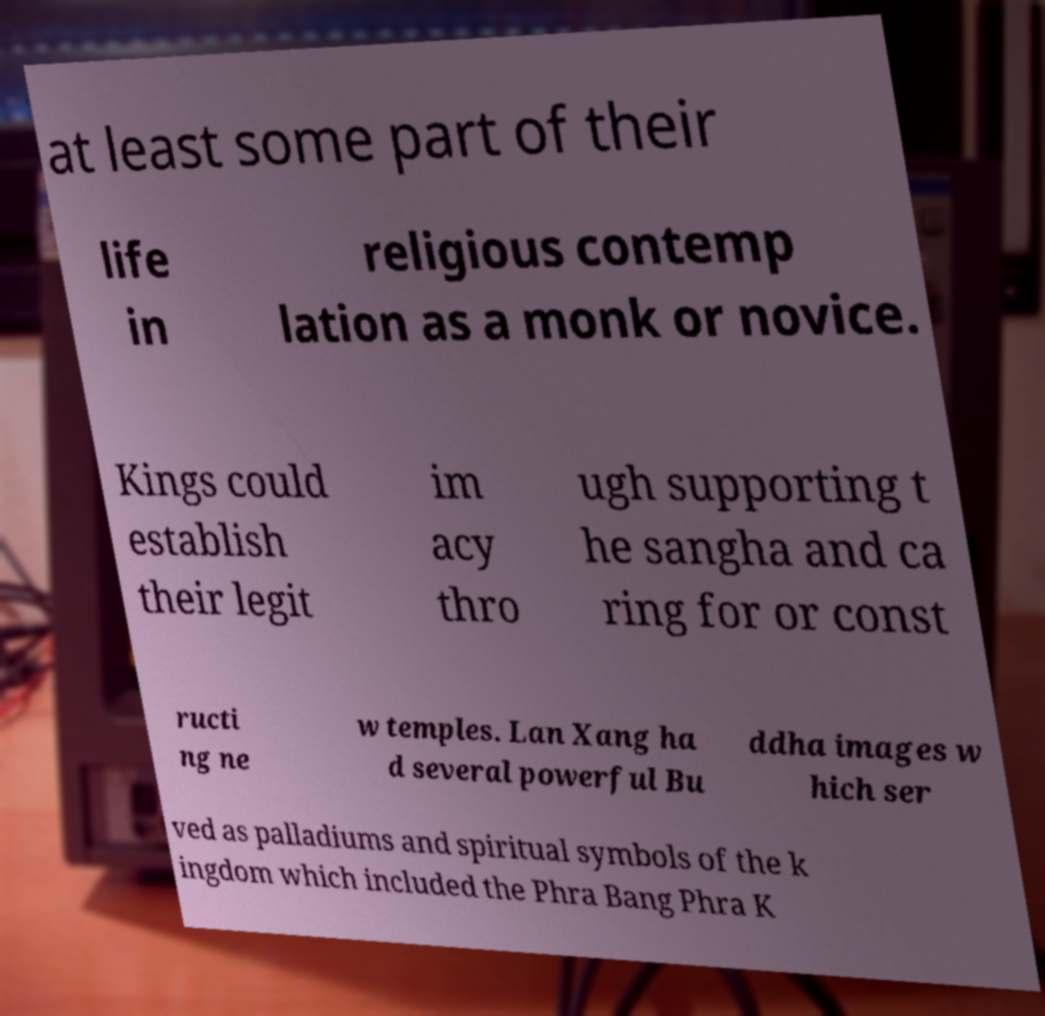Can you accurately transcribe the text from the provided image for me? at least some part of their life in religious contemp lation as a monk or novice. Kings could establish their legit im acy thro ugh supporting t he sangha and ca ring for or const ructi ng ne w temples. Lan Xang ha d several powerful Bu ddha images w hich ser ved as palladiums and spiritual symbols of the k ingdom which included the Phra Bang Phra K 